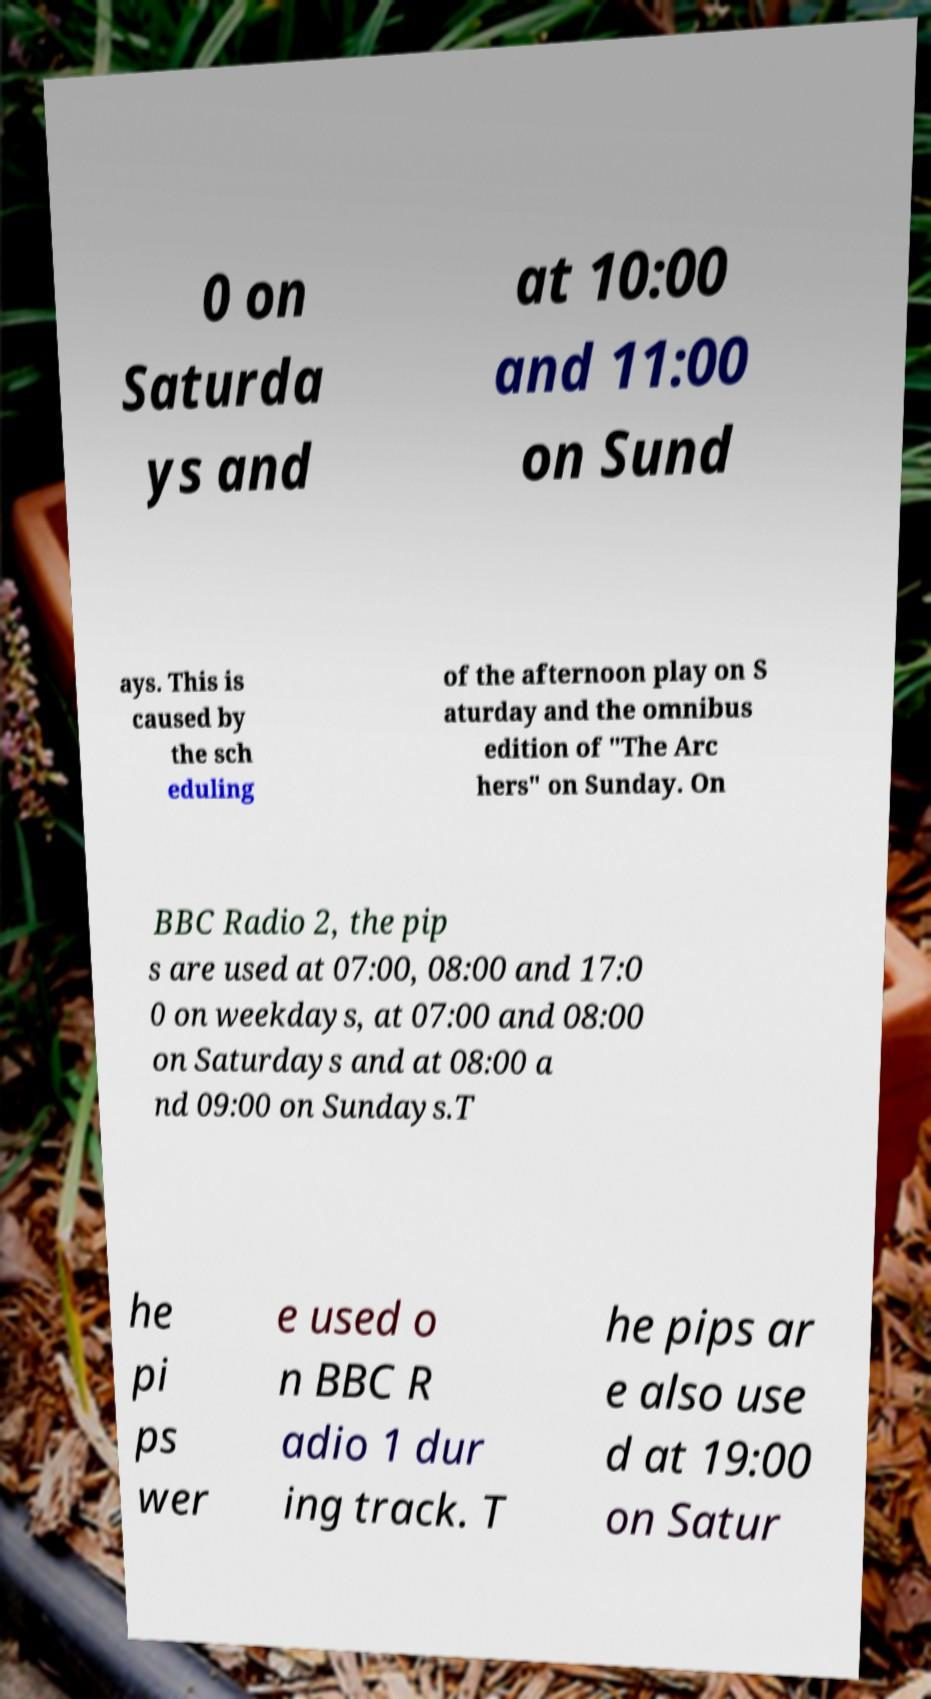Can you read and provide the text displayed in the image?This photo seems to have some interesting text. Can you extract and type it out for me? 0 on Saturda ys and at 10:00 and 11:00 on Sund ays. This is caused by the sch eduling of the afternoon play on S aturday and the omnibus edition of "The Arc hers" on Sunday. On BBC Radio 2, the pip s are used at 07:00, 08:00 and 17:0 0 on weekdays, at 07:00 and 08:00 on Saturdays and at 08:00 a nd 09:00 on Sundays.T he pi ps wer e used o n BBC R adio 1 dur ing track. T he pips ar e also use d at 19:00 on Satur 